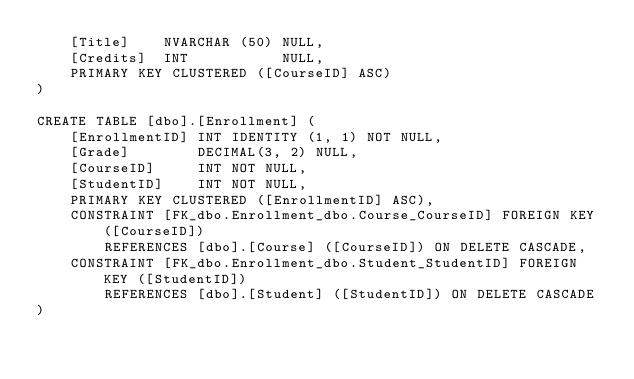<code> <loc_0><loc_0><loc_500><loc_500><_SQL_>    [Title]    NVARCHAR (50) NULL,
    [Credits]  INT           NULL,
    PRIMARY KEY CLUSTERED ([CourseID] ASC)
)

CREATE TABLE [dbo].[Enrollment] (
    [EnrollmentID] INT IDENTITY (1, 1) NOT NULL,
    [Grade]        DECIMAL(3, 2) NULL,
    [CourseID]     INT NOT NULL,
    [StudentID]    INT NOT NULL,
    PRIMARY KEY CLUSTERED ([EnrollmentID] ASC),
    CONSTRAINT [FK_dbo.Enrollment_dbo.Course_CourseID] FOREIGN KEY ([CourseID]) 
        REFERENCES [dbo].[Course] ([CourseID]) ON DELETE CASCADE,
    CONSTRAINT [FK_dbo.Enrollment_dbo.Student_StudentID] FOREIGN KEY ([StudentID]) 
        REFERENCES [dbo].[Student] ([StudentID]) ON DELETE CASCADE
)</code> 